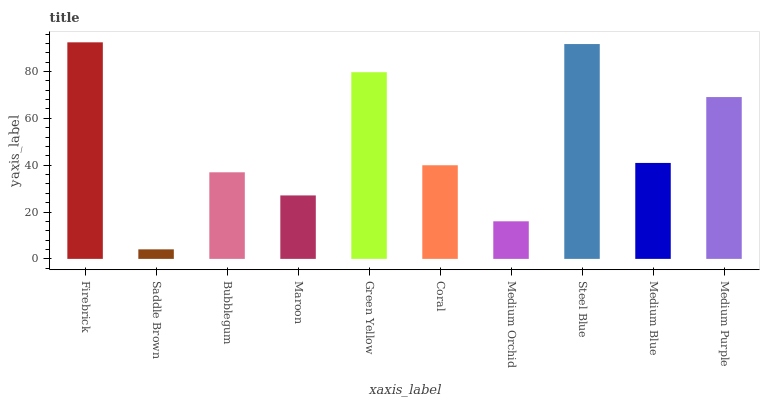Is Saddle Brown the minimum?
Answer yes or no. Yes. Is Firebrick the maximum?
Answer yes or no. Yes. Is Bubblegum the minimum?
Answer yes or no. No. Is Bubblegum the maximum?
Answer yes or no. No. Is Bubblegum greater than Saddle Brown?
Answer yes or no. Yes. Is Saddle Brown less than Bubblegum?
Answer yes or no. Yes. Is Saddle Brown greater than Bubblegum?
Answer yes or no. No. Is Bubblegum less than Saddle Brown?
Answer yes or no. No. Is Medium Blue the high median?
Answer yes or no. Yes. Is Coral the low median?
Answer yes or no. Yes. Is Medium Orchid the high median?
Answer yes or no. No. Is Maroon the low median?
Answer yes or no. No. 